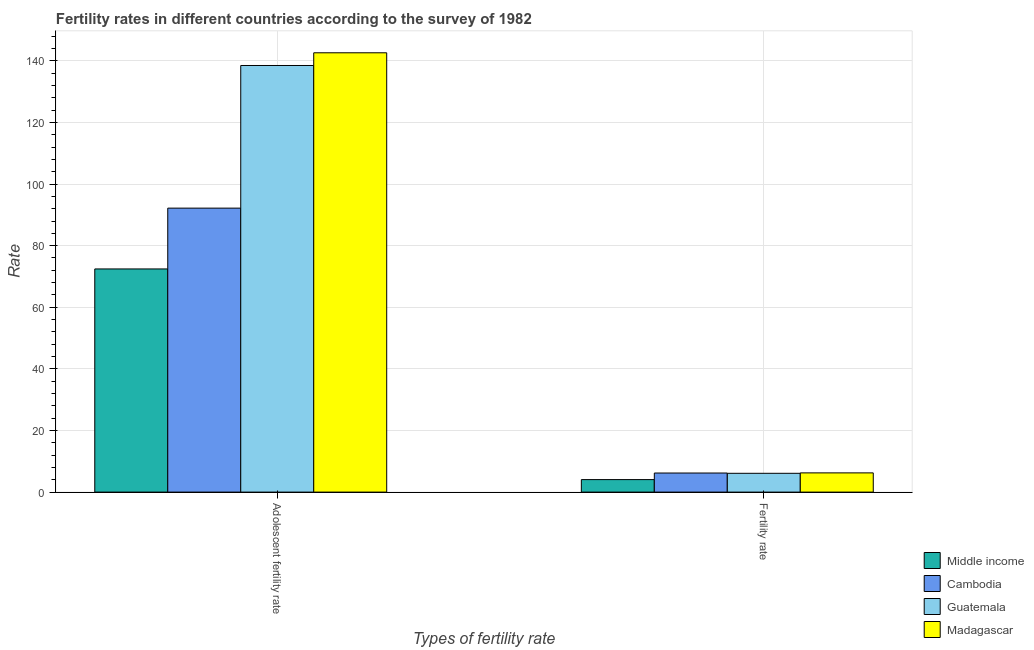How many bars are there on the 1st tick from the right?
Provide a succinct answer. 4. What is the label of the 2nd group of bars from the left?
Offer a very short reply. Fertility rate. What is the adolescent fertility rate in Middle income?
Offer a very short reply. 72.45. Across all countries, what is the maximum adolescent fertility rate?
Provide a short and direct response. 142.62. Across all countries, what is the minimum adolescent fertility rate?
Ensure brevity in your answer.  72.45. In which country was the fertility rate maximum?
Your response must be concise. Madagascar. In which country was the adolescent fertility rate minimum?
Provide a short and direct response. Middle income. What is the total adolescent fertility rate in the graph?
Give a very brief answer. 445.75. What is the difference between the fertility rate in Madagascar and that in Guatemala?
Your response must be concise. 0.13. What is the difference between the adolescent fertility rate in Madagascar and the fertility rate in Cambodia?
Offer a terse response. 136.42. What is the average adolescent fertility rate per country?
Give a very brief answer. 111.44. What is the difference between the adolescent fertility rate and fertility rate in Madagascar?
Your answer should be very brief. 136.38. In how many countries, is the adolescent fertility rate greater than 68 ?
Your answer should be compact. 4. What is the ratio of the fertility rate in Madagascar to that in Guatemala?
Ensure brevity in your answer.  1.02. In how many countries, is the fertility rate greater than the average fertility rate taken over all countries?
Provide a short and direct response. 3. What does the 4th bar from the left in Fertility rate represents?
Provide a succinct answer. Madagascar. How many bars are there?
Your answer should be very brief. 8. What is the difference between two consecutive major ticks on the Y-axis?
Provide a short and direct response. 20. Are the values on the major ticks of Y-axis written in scientific E-notation?
Provide a succinct answer. No. What is the title of the graph?
Offer a terse response. Fertility rates in different countries according to the survey of 1982. Does "Burundi" appear as one of the legend labels in the graph?
Provide a succinct answer. No. What is the label or title of the X-axis?
Give a very brief answer. Types of fertility rate. What is the label or title of the Y-axis?
Keep it short and to the point. Rate. What is the Rate in Middle income in Adolescent fertility rate?
Keep it short and to the point. 72.45. What is the Rate of Cambodia in Adolescent fertility rate?
Make the answer very short. 92.19. What is the Rate in Guatemala in Adolescent fertility rate?
Provide a short and direct response. 138.49. What is the Rate in Madagascar in Adolescent fertility rate?
Offer a very short reply. 142.62. What is the Rate of Middle income in Fertility rate?
Your response must be concise. 4.06. What is the Rate of Cambodia in Fertility rate?
Offer a very short reply. 6.19. What is the Rate in Guatemala in Fertility rate?
Ensure brevity in your answer.  6.11. What is the Rate of Madagascar in Fertility rate?
Offer a very short reply. 6.24. Across all Types of fertility rate, what is the maximum Rate in Middle income?
Keep it short and to the point. 72.45. Across all Types of fertility rate, what is the maximum Rate of Cambodia?
Ensure brevity in your answer.  92.19. Across all Types of fertility rate, what is the maximum Rate in Guatemala?
Keep it short and to the point. 138.49. Across all Types of fertility rate, what is the maximum Rate of Madagascar?
Keep it short and to the point. 142.62. Across all Types of fertility rate, what is the minimum Rate of Middle income?
Your response must be concise. 4.06. Across all Types of fertility rate, what is the minimum Rate of Cambodia?
Your answer should be compact. 6.19. Across all Types of fertility rate, what is the minimum Rate in Guatemala?
Offer a terse response. 6.11. Across all Types of fertility rate, what is the minimum Rate in Madagascar?
Your response must be concise. 6.24. What is the total Rate of Middle income in the graph?
Your response must be concise. 76.5. What is the total Rate of Cambodia in the graph?
Provide a short and direct response. 98.38. What is the total Rate in Guatemala in the graph?
Give a very brief answer. 144.6. What is the total Rate of Madagascar in the graph?
Provide a short and direct response. 148.86. What is the difference between the Rate of Middle income in Adolescent fertility rate and that in Fertility rate?
Provide a succinct answer. 68.39. What is the difference between the Rate in Cambodia in Adolescent fertility rate and that in Fertility rate?
Offer a terse response. 85.99. What is the difference between the Rate of Guatemala in Adolescent fertility rate and that in Fertility rate?
Ensure brevity in your answer.  132.39. What is the difference between the Rate of Madagascar in Adolescent fertility rate and that in Fertility rate?
Provide a short and direct response. 136.38. What is the difference between the Rate in Middle income in Adolescent fertility rate and the Rate in Cambodia in Fertility rate?
Give a very brief answer. 66.25. What is the difference between the Rate in Middle income in Adolescent fertility rate and the Rate in Guatemala in Fertility rate?
Give a very brief answer. 66.34. What is the difference between the Rate of Middle income in Adolescent fertility rate and the Rate of Madagascar in Fertility rate?
Your answer should be compact. 66.21. What is the difference between the Rate in Cambodia in Adolescent fertility rate and the Rate in Guatemala in Fertility rate?
Provide a succinct answer. 86.08. What is the difference between the Rate of Cambodia in Adolescent fertility rate and the Rate of Madagascar in Fertility rate?
Offer a very short reply. 85.95. What is the difference between the Rate in Guatemala in Adolescent fertility rate and the Rate in Madagascar in Fertility rate?
Offer a very short reply. 132.25. What is the average Rate of Middle income per Types of fertility rate?
Offer a very short reply. 38.25. What is the average Rate of Cambodia per Types of fertility rate?
Make the answer very short. 49.19. What is the average Rate of Guatemala per Types of fertility rate?
Ensure brevity in your answer.  72.3. What is the average Rate of Madagascar per Types of fertility rate?
Provide a short and direct response. 74.43. What is the difference between the Rate of Middle income and Rate of Cambodia in Adolescent fertility rate?
Give a very brief answer. -19.74. What is the difference between the Rate in Middle income and Rate in Guatemala in Adolescent fertility rate?
Ensure brevity in your answer.  -66.05. What is the difference between the Rate in Middle income and Rate in Madagascar in Adolescent fertility rate?
Give a very brief answer. -70.17. What is the difference between the Rate of Cambodia and Rate of Guatemala in Adolescent fertility rate?
Offer a terse response. -46.31. What is the difference between the Rate of Cambodia and Rate of Madagascar in Adolescent fertility rate?
Keep it short and to the point. -50.43. What is the difference between the Rate in Guatemala and Rate in Madagascar in Adolescent fertility rate?
Offer a very short reply. -4.12. What is the difference between the Rate of Middle income and Rate of Cambodia in Fertility rate?
Offer a terse response. -2.14. What is the difference between the Rate in Middle income and Rate in Guatemala in Fertility rate?
Offer a terse response. -2.05. What is the difference between the Rate in Middle income and Rate in Madagascar in Fertility rate?
Your answer should be very brief. -2.18. What is the difference between the Rate of Cambodia and Rate of Guatemala in Fertility rate?
Provide a short and direct response. 0.09. What is the difference between the Rate of Cambodia and Rate of Madagascar in Fertility rate?
Offer a very short reply. -0.05. What is the difference between the Rate in Guatemala and Rate in Madagascar in Fertility rate?
Give a very brief answer. -0.14. What is the ratio of the Rate in Middle income in Adolescent fertility rate to that in Fertility rate?
Make the answer very short. 17.86. What is the ratio of the Rate of Cambodia in Adolescent fertility rate to that in Fertility rate?
Offer a terse response. 14.89. What is the ratio of the Rate in Guatemala in Adolescent fertility rate to that in Fertility rate?
Provide a short and direct response. 22.69. What is the ratio of the Rate in Madagascar in Adolescent fertility rate to that in Fertility rate?
Ensure brevity in your answer.  22.86. What is the difference between the highest and the second highest Rate of Middle income?
Your answer should be compact. 68.39. What is the difference between the highest and the second highest Rate of Cambodia?
Your answer should be compact. 85.99. What is the difference between the highest and the second highest Rate in Guatemala?
Offer a very short reply. 132.39. What is the difference between the highest and the second highest Rate of Madagascar?
Your response must be concise. 136.38. What is the difference between the highest and the lowest Rate of Middle income?
Offer a very short reply. 68.39. What is the difference between the highest and the lowest Rate of Cambodia?
Keep it short and to the point. 85.99. What is the difference between the highest and the lowest Rate of Guatemala?
Give a very brief answer. 132.39. What is the difference between the highest and the lowest Rate in Madagascar?
Offer a very short reply. 136.38. 